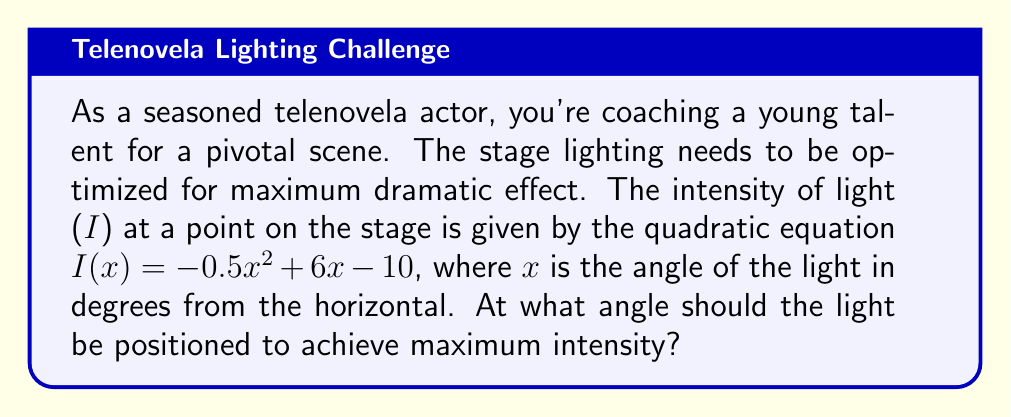Teach me how to tackle this problem. To find the angle that maximizes light intensity, we need to find the vertex of the parabola described by the quadratic equation. The steps are as follows:

1) The quadratic equation is in the form $I(x) = ax^2 + bx + c$, where:
   $a = -0.5$
   $b = 6$
   $c = -10$

2) For a quadratic equation in this form, the x-coordinate of the vertex is given by $x = -\frac{b}{2a}$

3) Substituting our values:
   $$x = -\frac{6}{2(-0.5)} = -\frac{6}{-1} = 6$$

4) Therefore, the light intensity is maximized when $x = 6$ degrees.

5) To verify, we can calculate the intensity at this point:
   $$I(6) = -0.5(6)^2 + 6(6) - 10$$
   $$= -0.5(36) + 36 - 10$$
   $$= -18 + 36 - 10 = 8$$

6) We can also check points on either side to confirm this is indeed the maximum:
   $$I(5) = -0.5(5)^2 + 6(5) - 10 = -12.5 + 30 - 10 = 7.5$$
   $$I(7) = -0.5(7)^2 + 6(7) - 10 = -24.5 + 42 - 10 = 7.5$$

Both of these values are less than $I(6) = 8$, confirming that 6 degrees is indeed the angle that maximizes light intensity.
Answer: 6 degrees 